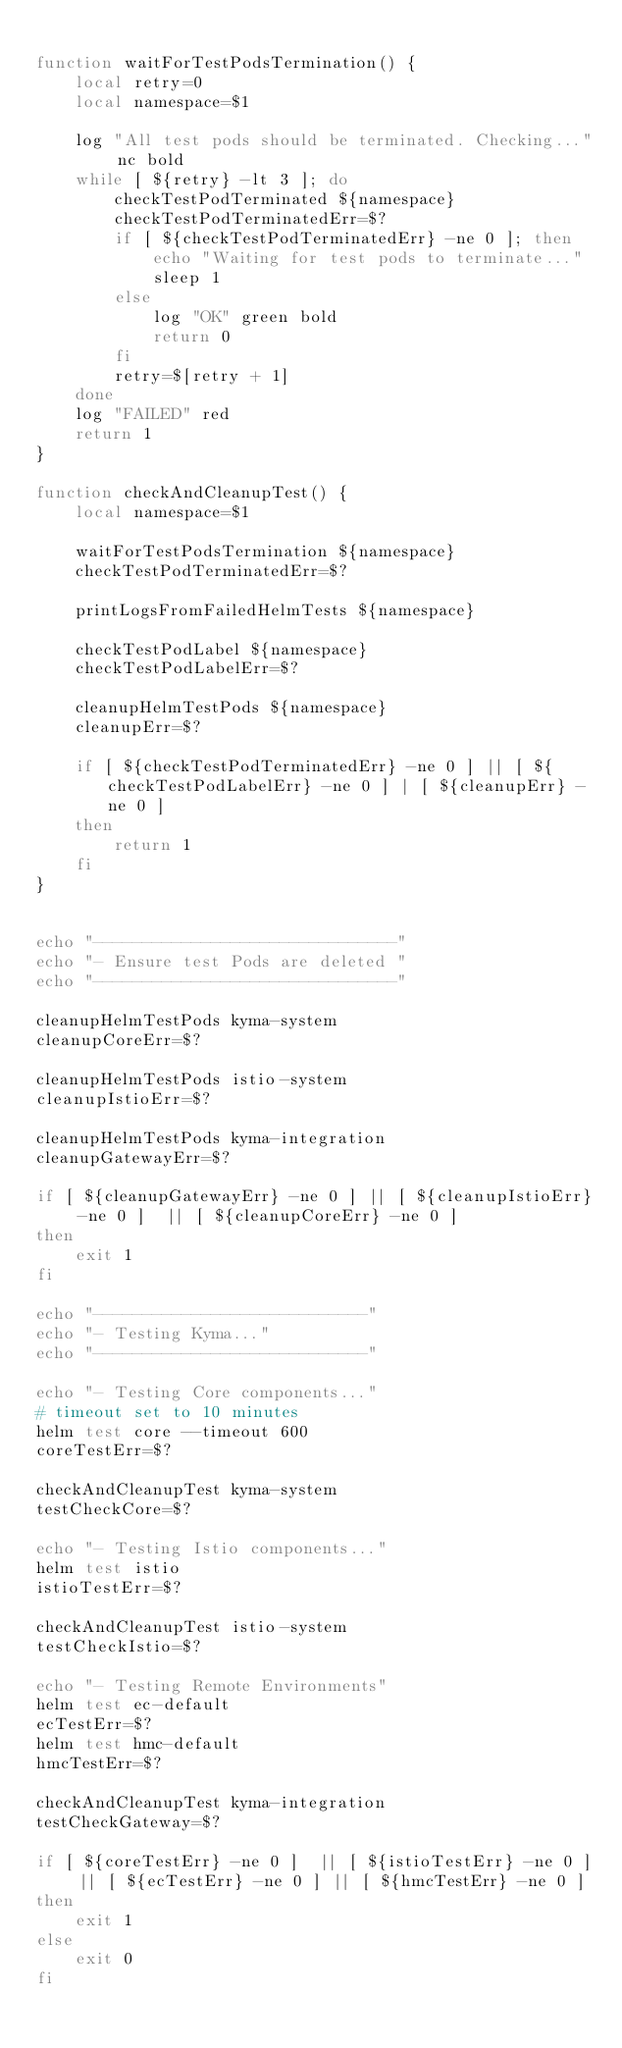Convert code to text. <code><loc_0><loc_0><loc_500><loc_500><_Bash_>
function waitForTestPodsTermination() {
    local retry=0
    local namespace=$1

    log "All test pods should be terminated. Checking..." nc bold
    while [ ${retry} -lt 3 ]; do
        checkTestPodTerminated ${namespace}
        checkTestPodTerminatedErr=$?
        if [ ${checkTestPodTerminatedErr} -ne 0 ]; then
            echo "Waiting for test pods to terminate..."
            sleep 1
        else
            log "OK" green bold
            return 0
        fi
        retry=$[retry + 1]
    done
    log "FAILED" red
    return 1
}

function checkAndCleanupTest() {
    local namespace=$1

    waitForTestPodsTermination ${namespace}
    checkTestPodTerminatedErr=$?

    printLogsFromFailedHelmTests ${namespace}

    checkTestPodLabel ${namespace}
    checkTestPodLabelErr=$?

    cleanupHelmTestPods ${namespace}
    cleanupErr=$?

    if [ ${checkTestPodTerminatedErr} -ne 0 ] || [ ${checkTestPodLabelErr} -ne 0 ] | [ ${cleanupErr} -ne 0 ]
    then
        return 1
    fi
}


echo "-------------------------------"
echo "- Ensure test Pods are deleted "
echo "-------------------------------"

cleanupHelmTestPods kyma-system
cleanupCoreErr=$?

cleanupHelmTestPods istio-system
cleanupIstioErr=$?

cleanupHelmTestPods kyma-integration
cleanupGatewayErr=$?

if [ ${cleanupGatewayErr} -ne 0 ] || [ ${cleanupIstioErr} -ne 0 ]  || [ ${cleanupCoreErr} -ne 0 ]
then
    exit 1
fi

echo "----------------------------"
echo "- Testing Kyma..."
echo "----------------------------"

echo "- Testing Core components..."
# timeout set to 10 minutes
helm test core --timeout 600
coreTestErr=$?

checkAndCleanupTest kyma-system
testCheckCore=$?

echo "- Testing Istio components..."
helm test istio
istioTestErr=$?

checkAndCleanupTest istio-system
testCheckIstio=$?

echo "- Testing Remote Environments"
helm test ec-default
ecTestErr=$?
helm test hmc-default
hmcTestErr=$?

checkAndCleanupTest kyma-integration
testCheckGateway=$?

if [ ${coreTestErr} -ne 0 ]  || [ ${istioTestErr} -ne 0 ] || [ ${ecTestErr} -ne 0 ] || [ ${hmcTestErr} -ne 0 ]
then
    exit 1
else
    exit 0
fi
</code> 